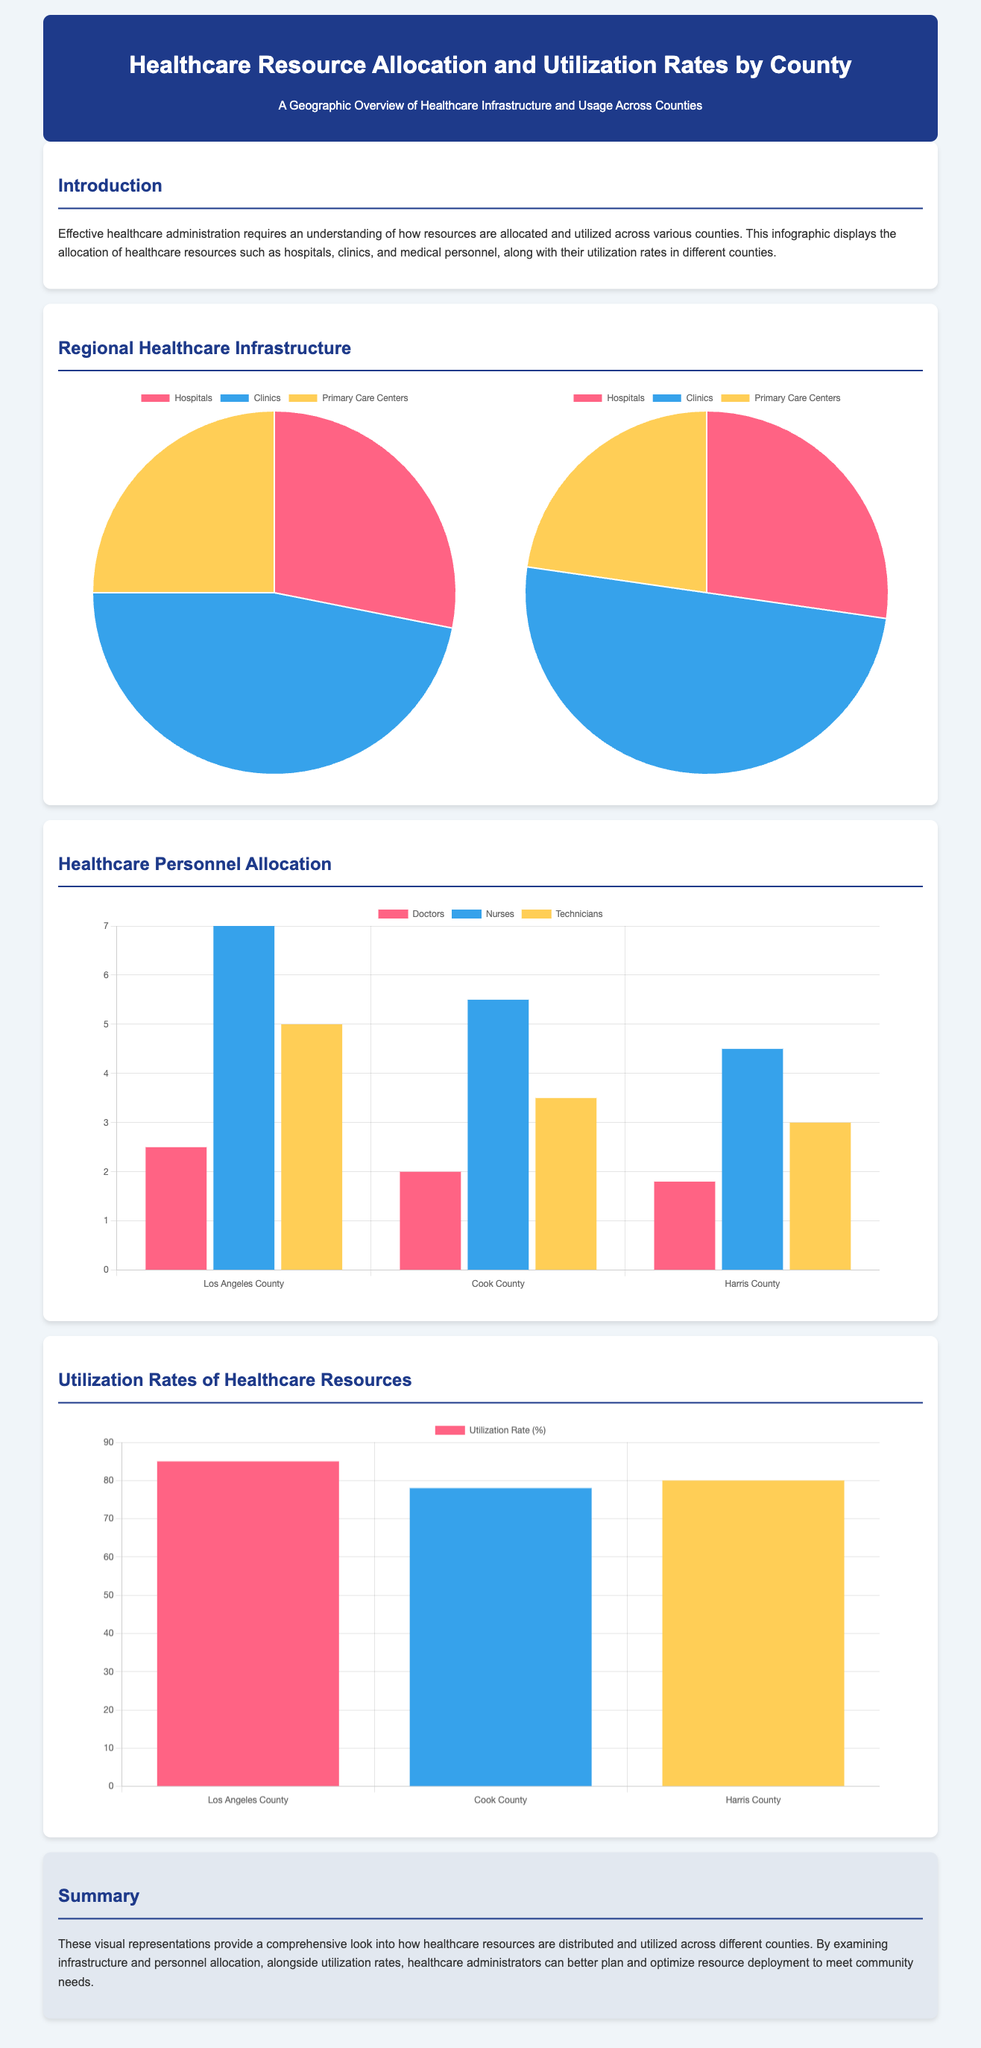What is the percentage of hospitals in Los Angeles County? The pie chart shows that hospitals constitute 45% of the healthcare facilities in Los Angeles County.
Answer: 45% What is the total number of clinics in Cook County? The pie chart indicates that there are 55 clinics in Cook County since they account for 55% of the facilities there.
Answer: 55 How many doctors are allocated per 1,000 residents in Harris County? The chart displays that there are 1.8 doctors per 1,000 residents in Harris County.
Answer: 1.8 What is the bed utilization rate in Los Angeles County? The bar graph indicates that the bed utilization rate is 85% in Los Angeles County.
Answer: 85% Which county has the highest number of nurses per 1,000 residents? The bar graph shows that Los Angeles County has the highest number of nurses per 1,000 residents, with a count of 7.0.
Answer: Los Angeles County What type of facility has the lowest distribution percentage in Cook County? The pie chart shows that Primary Care Centers have the lowest distribution percentage at 25% in Cook County.
Answer: Primary Care Centers What is the title of the infographic? The title of the infographic is stated in the header section.
Answer: Healthcare Resource Allocation and Utilization Rates by County How many total types of healthcare facilities are represented in the county charts? The pie charts for both counties represent a total of three types of healthcare facilities: Hospitals, Clinics, and Primary Care Centers.
Answer: 3 What is the color representation for technicians in the personnel allocation chart? The personnel allocation bar graph indicates that technicians are represented by the color yellow.
Answer: Yellow 